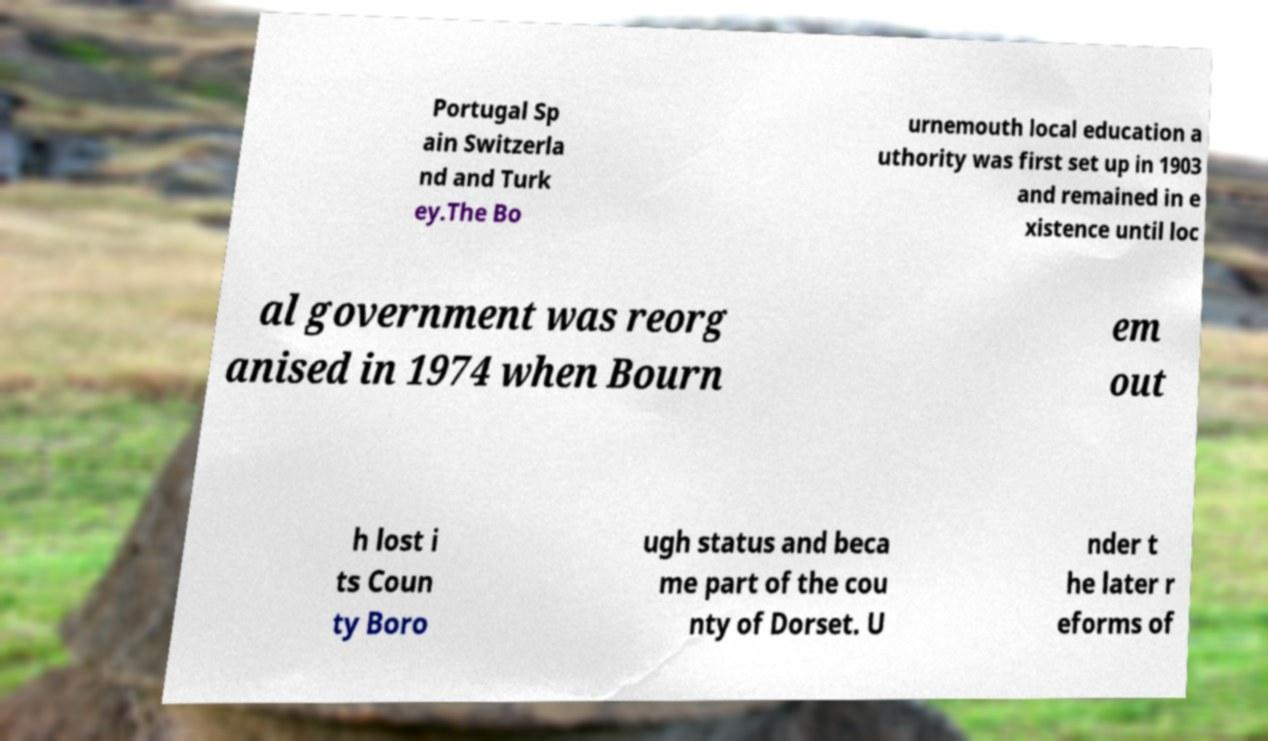For documentation purposes, I need the text within this image transcribed. Could you provide that? Portugal Sp ain Switzerla nd and Turk ey.The Bo urnemouth local education a uthority was first set up in 1903 and remained in e xistence until loc al government was reorg anised in 1974 when Bourn em out h lost i ts Coun ty Boro ugh status and beca me part of the cou nty of Dorset. U nder t he later r eforms of 